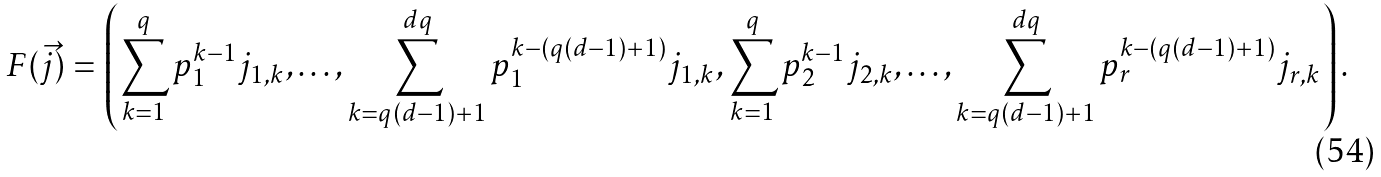<formula> <loc_0><loc_0><loc_500><loc_500>F ( \vec { j } ) = \left ( \sum _ { k = 1 } ^ { q } p _ { 1 } ^ { k - 1 } j _ { 1 , k } , \dots , \sum _ { k = q ( d - 1 ) + 1 } ^ { d q } p _ { 1 } ^ { k - ( q ( d - 1 ) + 1 ) } j _ { 1 , k } , \sum _ { k = 1 } ^ { q } p _ { 2 } ^ { k - 1 } j _ { 2 , k } , \dots , \sum _ { k = q ( d - 1 ) + 1 } ^ { d q } p _ { r } ^ { k - ( q ( d - 1 ) + 1 ) } j _ { r , k } \right ) .</formula> 